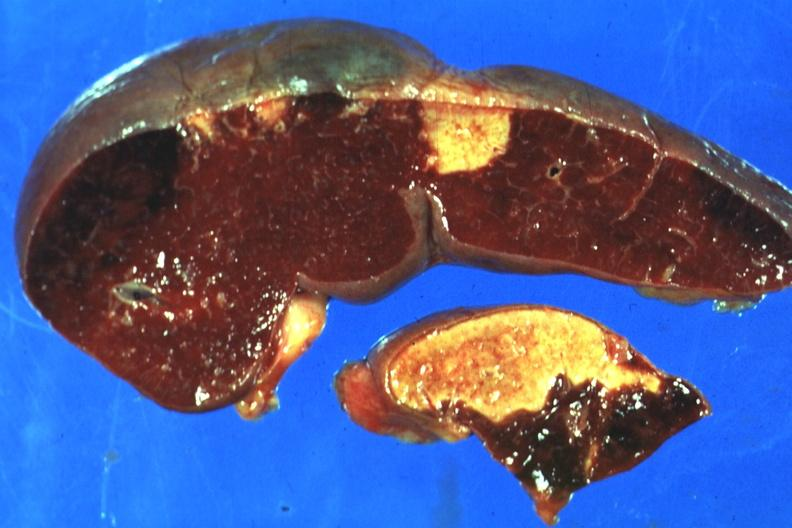how is excellent side with four infarcts shown which are days of age from nonbacterial endocarditis?
Answer the question using a single word or phrase. Several 